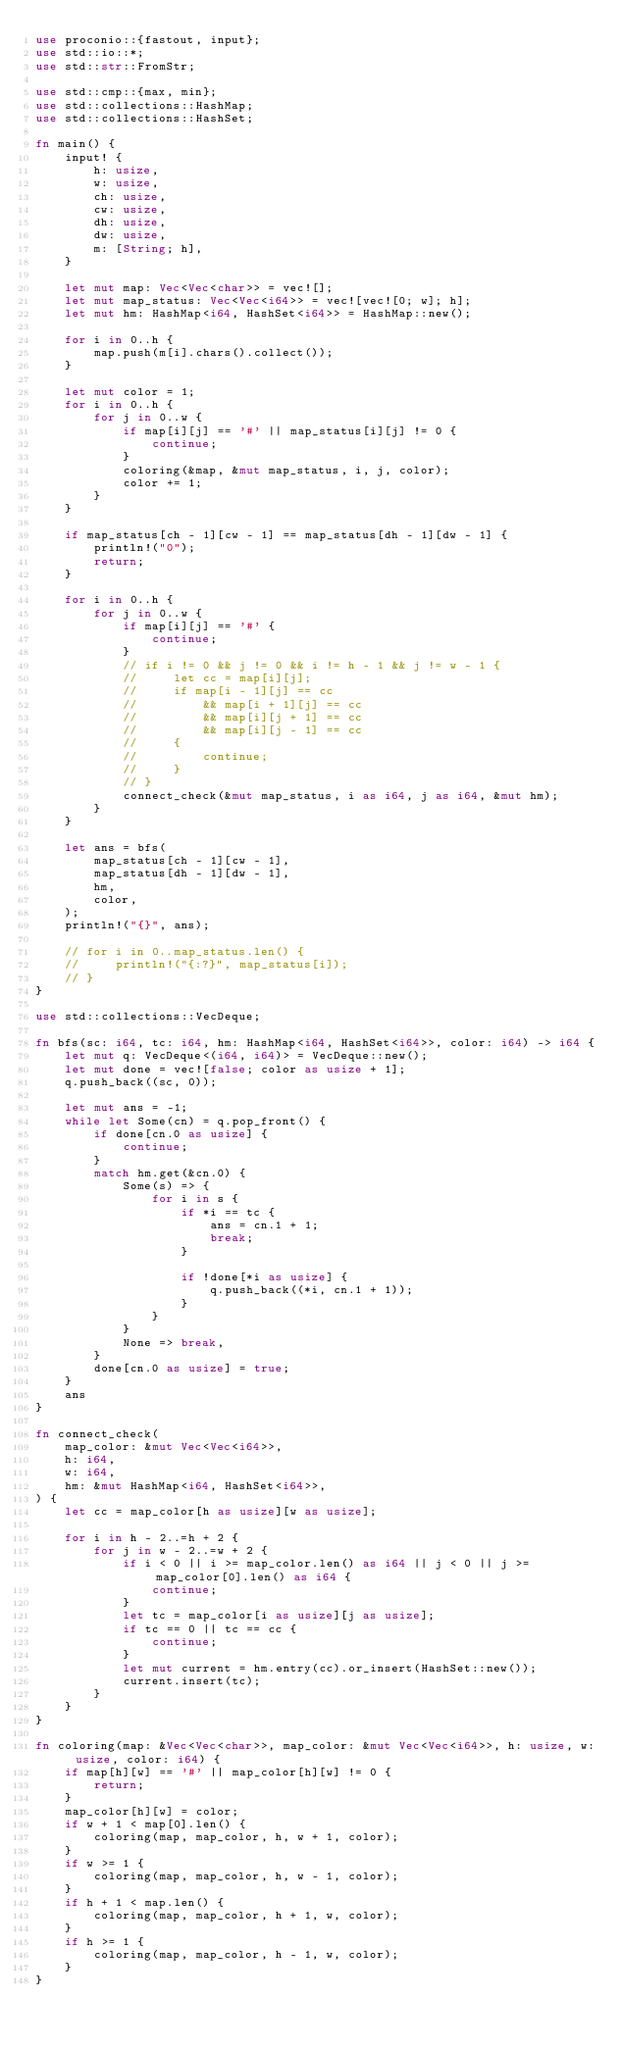Convert code to text. <code><loc_0><loc_0><loc_500><loc_500><_Rust_>use proconio::{fastout, input};
use std::io::*;
use std::str::FromStr;

use std::cmp::{max, min};
use std::collections::HashMap;
use std::collections::HashSet;

fn main() {
    input! {
        h: usize,
        w: usize,
        ch: usize,
        cw: usize,
        dh: usize,
        dw: usize,
        m: [String; h],
    }

    let mut map: Vec<Vec<char>> = vec![];
    let mut map_status: Vec<Vec<i64>> = vec![vec![0; w]; h];
    let mut hm: HashMap<i64, HashSet<i64>> = HashMap::new();

    for i in 0..h {
        map.push(m[i].chars().collect());
    }

    let mut color = 1;
    for i in 0..h {
        for j in 0..w {
            if map[i][j] == '#' || map_status[i][j] != 0 {
                continue;
            }
            coloring(&map, &mut map_status, i, j, color);
            color += 1;
        }
    }

    if map_status[ch - 1][cw - 1] == map_status[dh - 1][dw - 1] {
        println!("0");
        return;
    }

    for i in 0..h {
        for j in 0..w {
            if map[i][j] == '#' {
                continue;
            }
            // if i != 0 && j != 0 && i != h - 1 && j != w - 1 {
            //     let cc = map[i][j];
            //     if map[i - 1][j] == cc
            //         && map[i + 1][j] == cc
            //         && map[i][j + 1] == cc
            //         && map[i][j - 1] == cc
            //     {
            //         continue;
            //     }
            // }
            connect_check(&mut map_status, i as i64, j as i64, &mut hm);
        }
    }

    let ans = bfs(
        map_status[ch - 1][cw - 1],
        map_status[dh - 1][dw - 1],
        hm,
        color,
    );
    println!("{}", ans);

    // for i in 0..map_status.len() {
    //     println!("{:?}", map_status[i]);
    // }
}

use std::collections::VecDeque;

fn bfs(sc: i64, tc: i64, hm: HashMap<i64, HashSet<i64>>, color: i64) -> i64 {
    let mut q: VecDeque<(i64, i64)> = VecDeque::new();
    let mut done = vec![false; color as usize + 1];
    q.push_back((sc, 0));

    let mut ans = -1;
    while let Some(cn) = q.pop_front() {
        if done[cn.0 as usize] {
            continue;
        }
        match hm.get(&cn.0) {
            Some(s) => {
                for i in s {
                    if *i == tc {
                        ans = cn.1 + 1;
                        break;
                    }

                    if !done[*i as usize] {
                        q.push_back((*i, cn.1 + 1));
                    }
                }
            }
            None => break,
        }
        done[cn.0 as usize] = true;
    }
    ans
}

fn connect_check(
    map_color: &mut Vec<Vec<i64>>,
    h: i64,
    w: i64,
    hm: &mut HashMap<i64, HashSet<i64>>,
) {
    let cc = map_color[h as usize][w as usize];

    for i in h - 2..=h + 2 {
        for j in w - 2..=w + 2 {
            if i < 0 || i >= map_color.len() as i64 || j < 0 || j >= map_color[0].len() as i64 {
                continue;
            }
            let tc = map_color[i as usize][j as usize];
            if tc == 0 || tc == cc {
                continue;
            }
            let mut current = hm.entry(cc).or_insert(HashSet::new());
            current.insert(tc);
        }
    }
}

fn coloring(map: &Vec<Vec<char>>, map_color: &mut Vec<Vec<i64>>, h: usize, w: usize, color: i64) {
    if map[h][w] == '#' || map_color[h][w] != 0 {
        return;
    }
    map_color[h][w] = color;
    if w + 1 < map[0].len() {
        coloring(map, map_color, h, w + 1, color);
    }
    if w >= 1 {
        coloring(map, map_color, h, w - 1, color);
    }
    if h + 1 < map.len() {
        coloring(map, map_color, h + 1, w, color);
    }
    if h >= 1 {
        coloring(map, map_color, h - 1, w, color);
    }
}
</code> 